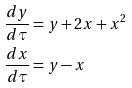<formula> <loc_0><loc_0><loc_500><loc_500>\frac { d y } { d \tau } & = y + 2 x + x ^ { 2 } \\ { \frac { d x } { d \tau } } & = y - x</formula> 